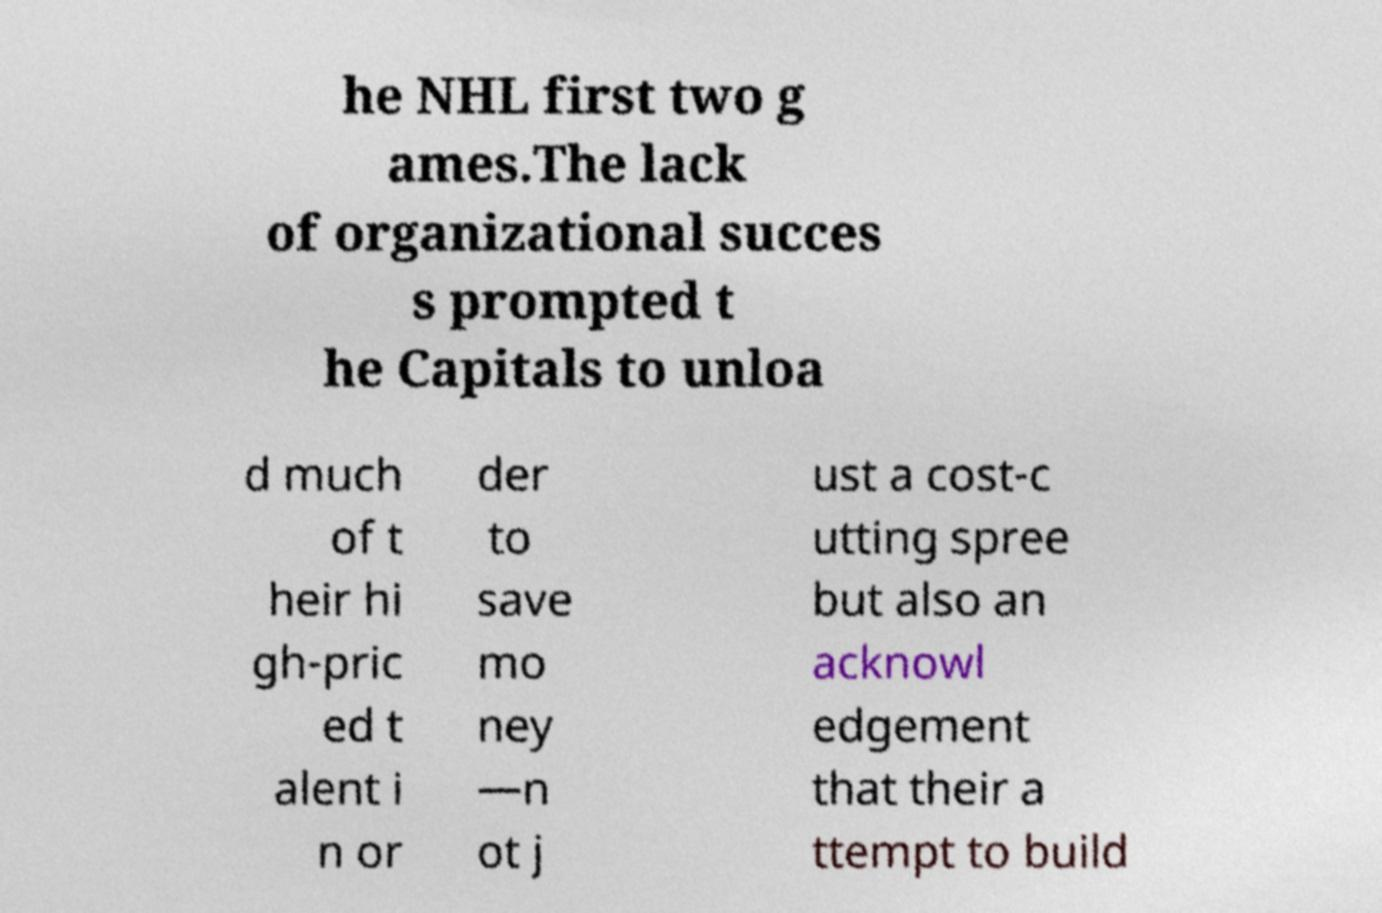Please identify and transcribe the text found in this image. he NHL first two g ames.The lack of organizational succes s prompted t he Capitals to unloa d much of t heir hi gh-pric ed t alent i n or der to save mo ney —n ot j ust a cost-c utting spree but also an acknowl edgement that their a ttempt to build 